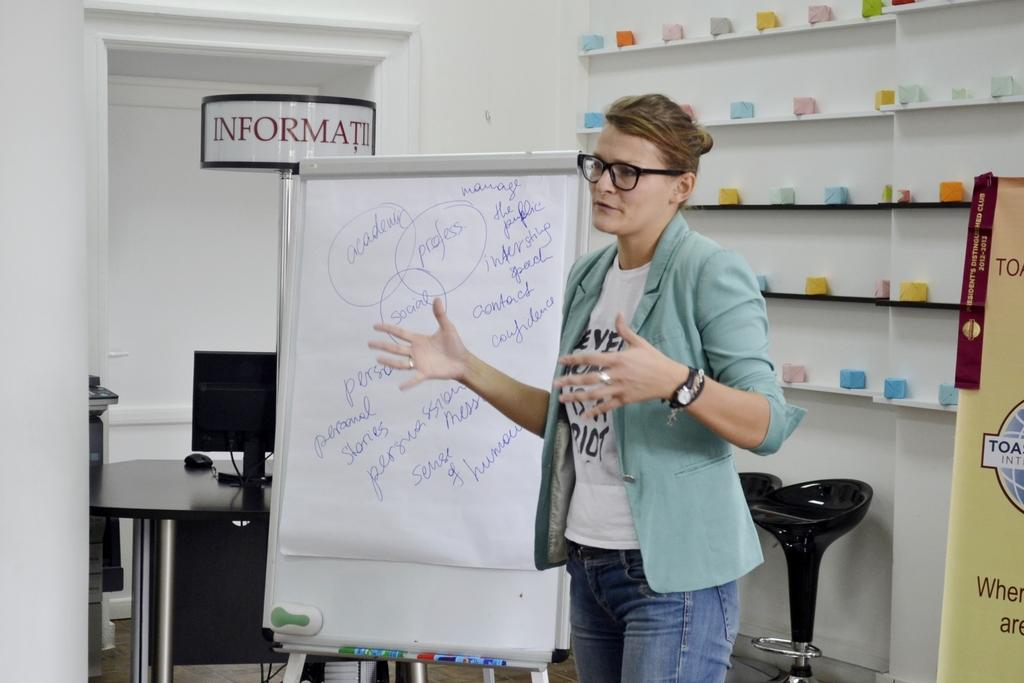What is the main subject in the image? There is a woman standing in the image. What can be seen beside the woman? There is a board beside the woman with writing on it. What is located behind the woman? There is a shelf behind the woman with objects on it. Can you see an owl flying in the image? There is no owl present in the image. Are there any balloons visible in the image? There is no mention of balloons in the provided facts, and therefore we cannot determine if any are present in the image. 